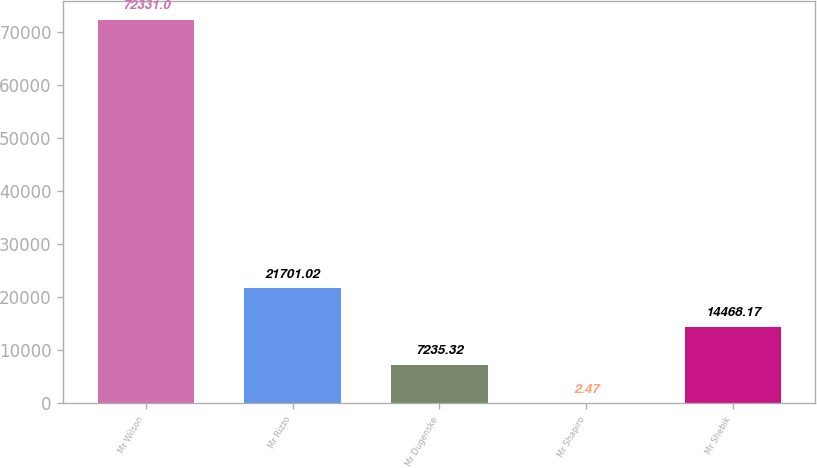Convert chart to OTSL. <chart><loc_0><loc_0><loc_500><loc_500><bar_chart><fcel>Mr Wilson<fcel>Mr Rizzo<fcel>Mr Dugenske<fcel>Mr Shapiro<fcel>Mr Shebik<nl><fcel>72331<fcel>21701<fcel>7235.32<fcel>2.47<fcel>14468.2<nl></chart> 